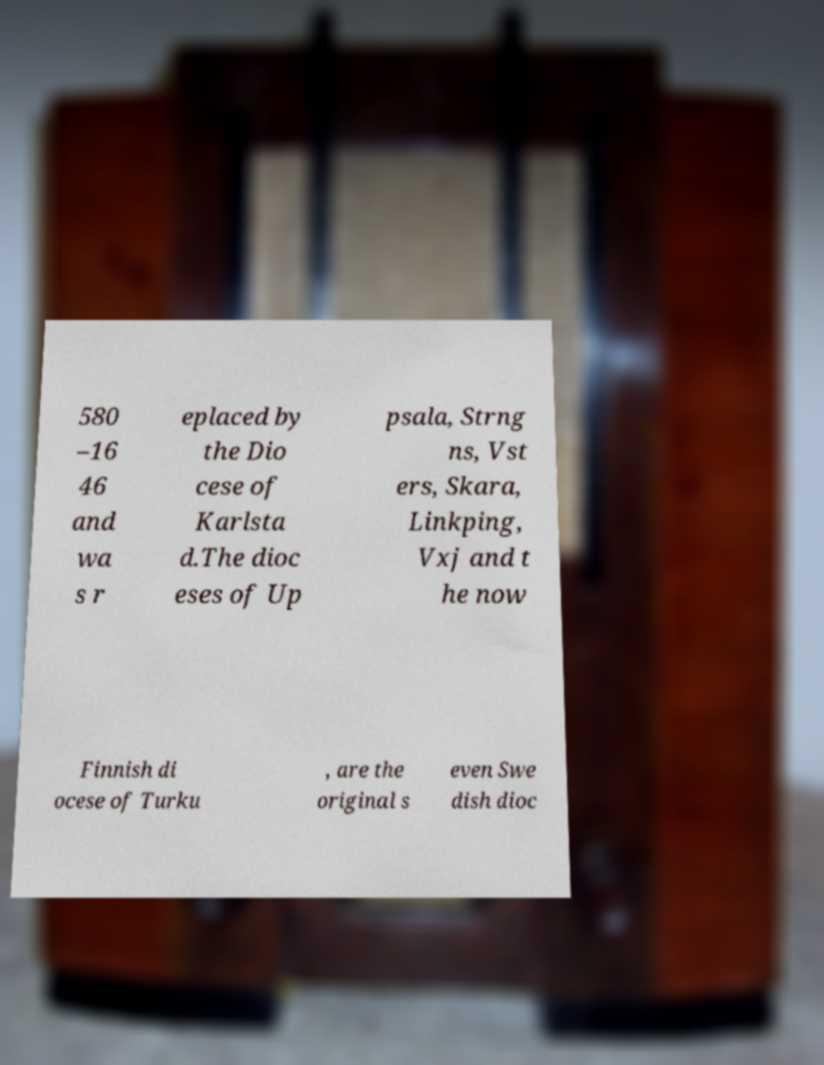Can you read and provide the text displayed in the image?This photo seems to have some interesting text. Can you extract and type it out for me? 580 –16 46 and wa s r eplaced by the Dio cese of Karlsta d.The dioc eses of Up psala, Strng ns, Vst ers, Skara, Linkping, Vxj and t he now Finnish di ocese of Turku , are the original s even Swe dish dioc 